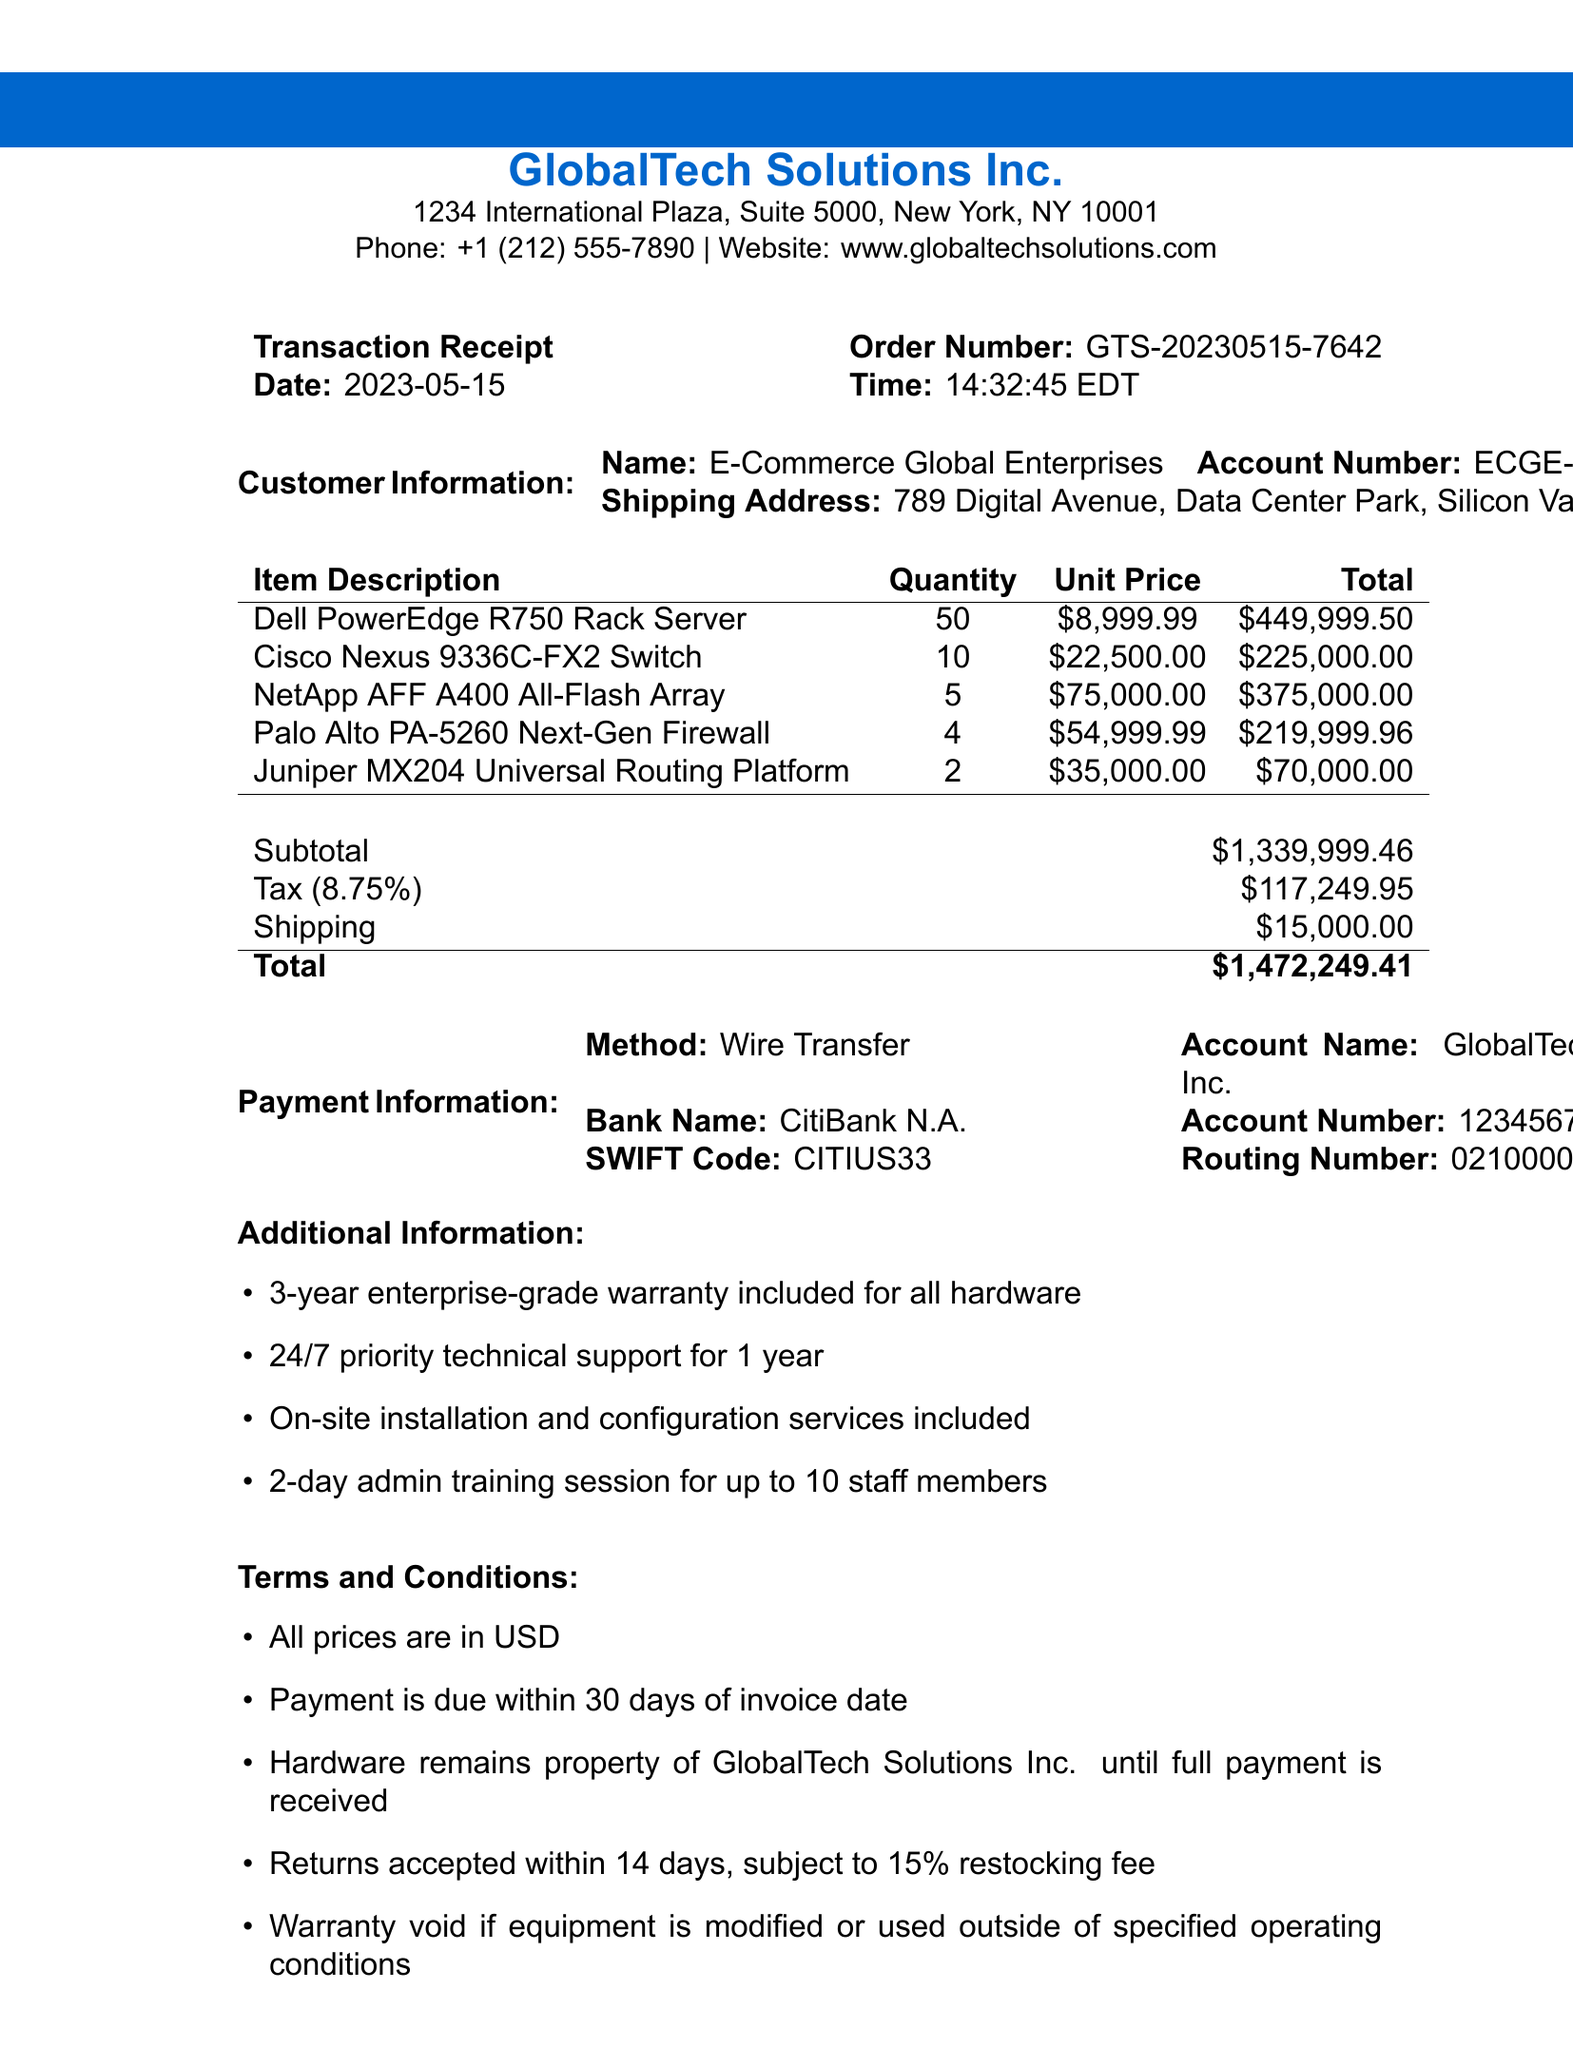What is the order number? The order number is stated in the transaction details section of the document.
Answer: GTS-20230515-7642 What is the shipping address? The shipping address is provided under customer information in the document.
Answer: 789 Digital Avenue, Data Center Park, Silicon Valley, CA 94085 How many Dell PowerEdge R750 Rack Servers were purchased? The quantity of Dell PowerEdge R750 Rack Servers is mentioned in the items list of the receipt.
Answer: 50 What is the subtotal amount? The subtotal amount is displayed in the summary section of the receipt.
Answer: $1,339,999.46 Who is the customer? The customer name is provided in the customer information section of the receipt.
Answer: E-Commerce Global Enterprises What is the tax amount? The tax amount is included in the summary section of the document.
Answer: $117,249.95 What payment method was used? The payment method is noted in the payment information section of the receipt.
Answer: Wire Transfer What warranty period is included? The warranty period is mentioned in the additional information section of the document.
Answer: 3-year How many staff members are included in the admin training session? The number of staff members for training is specified in the additional information section.
Answer: 10 What is the shipping cost? The shipping cost is listed in the summary section of the receipt.
Answer: $15,000.00 